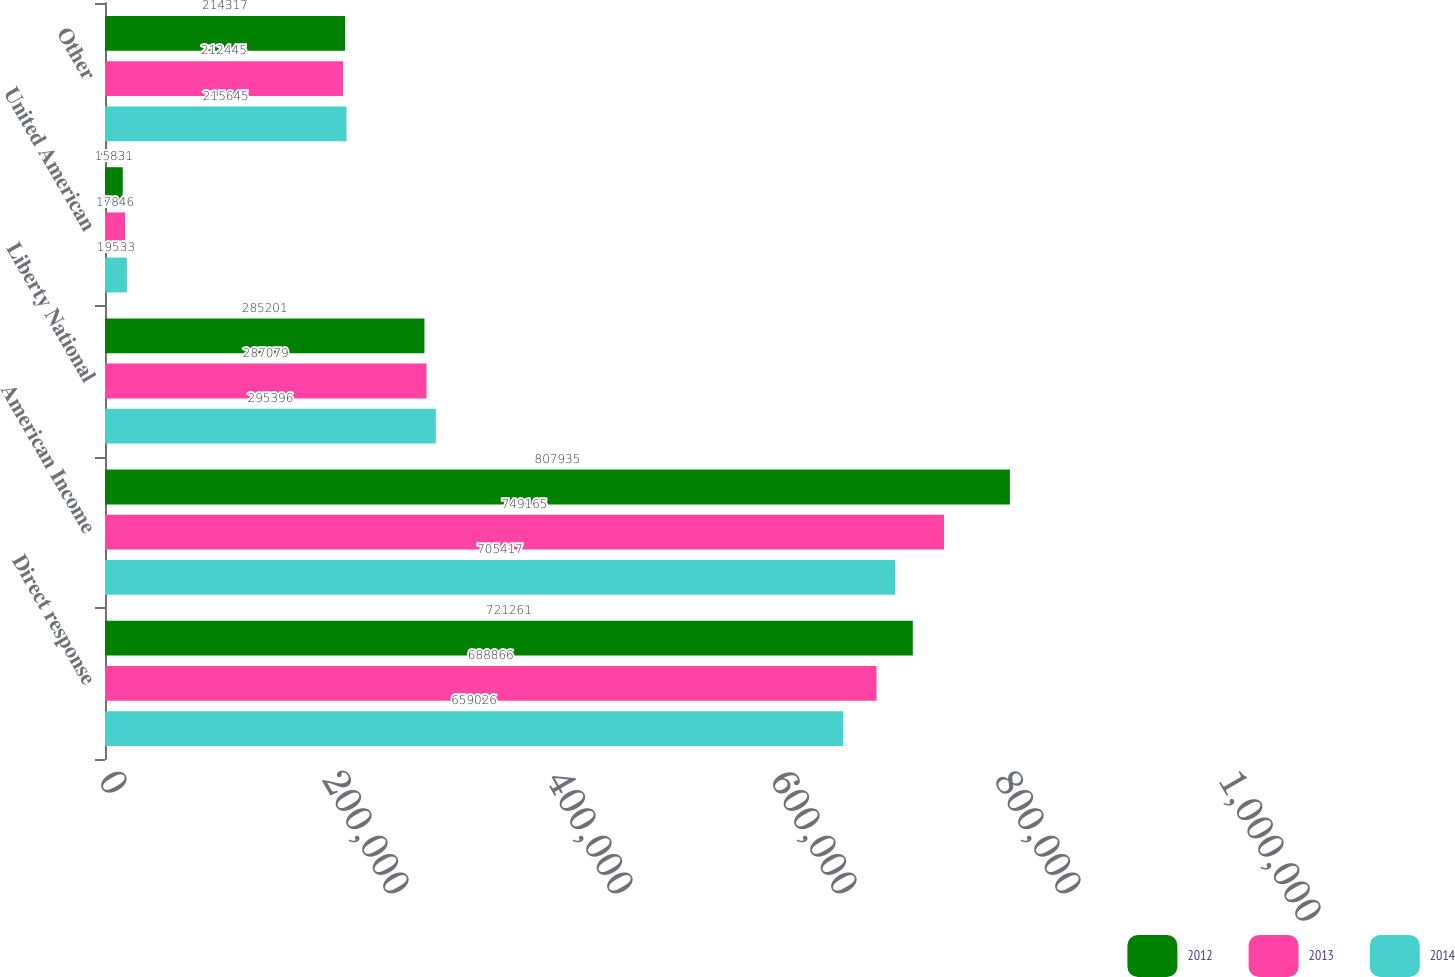<chart> <loc_0><loc_0><loc_500><loc_500><stacked_bar_chart><ecel><fcel>Direct response<fcel>American Income<fcel>Liberty National<fcel>United American<fcel>Other<nl><fcel>2012<fcel>721261<fcel>807935<fcel>285201<fcel>15831<fcel>214317<nl><fcel>2013<fcel>688866<fcel>749165<fcel>287079<fcel>17846<fcel>212445<nl><fcel>2014<fcel>659026<fcel>705417<fcel>295396<fcel>19533<fcel>215645<nl></chart> 